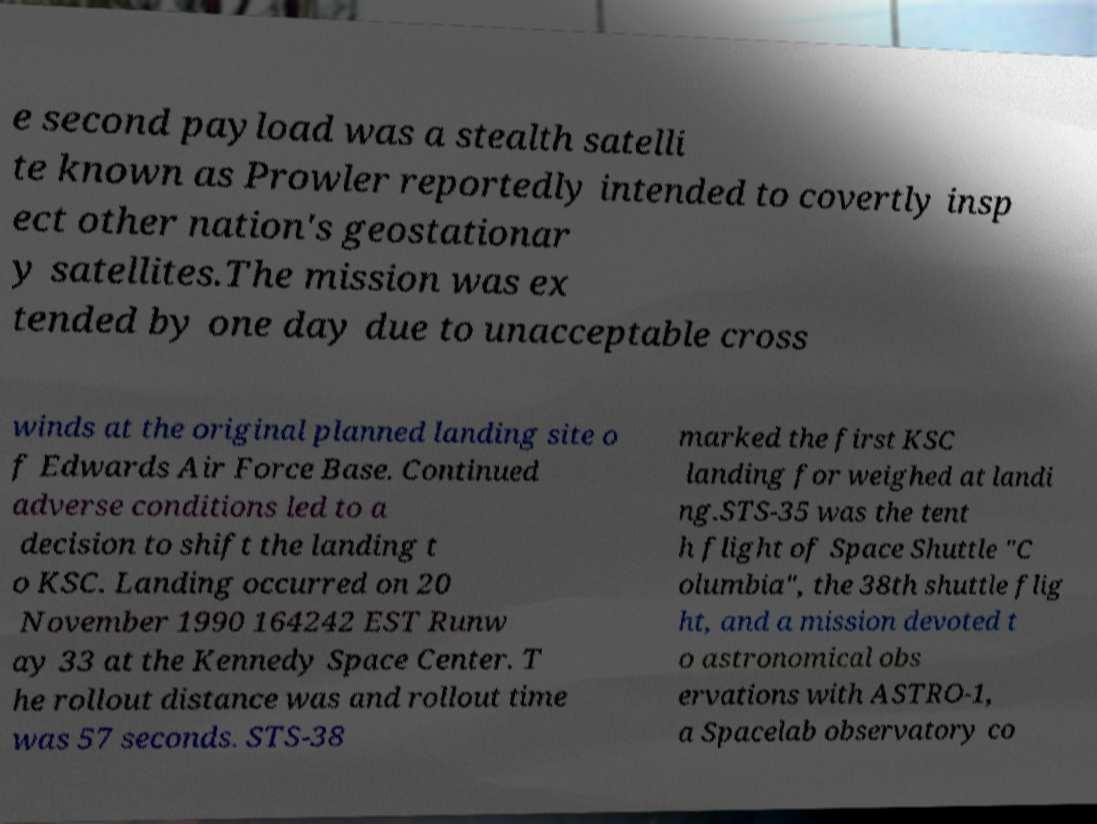I need the written content from this picture converted into text. Can you do that? e second payload was a stealth satelli te known as Prowler reportedly intended to covertly insp ect other nation's geostationar y satellites.The mission was ex tended by one day due to unacceptable cross winds at the original planned landing site o f Edwards Air Force Base. Continued adverse conditions led to a decision to shift the landing t o KSC. Landing occurred on 20 November 1990 164242 EST Runw ay 33 at the Kennedy Space Center. T he rollout distance was and rollout time was 57 seconds. STS-38 marked the first KSC landing for weighed at landi ng.STS-35 was the tent h flight of Space Shuttle "C olumbia", the 38th shuttle flig ht, and a mission devoted t o astronomical obs ervations with ASTRO-1, a Spacelab observatory co 